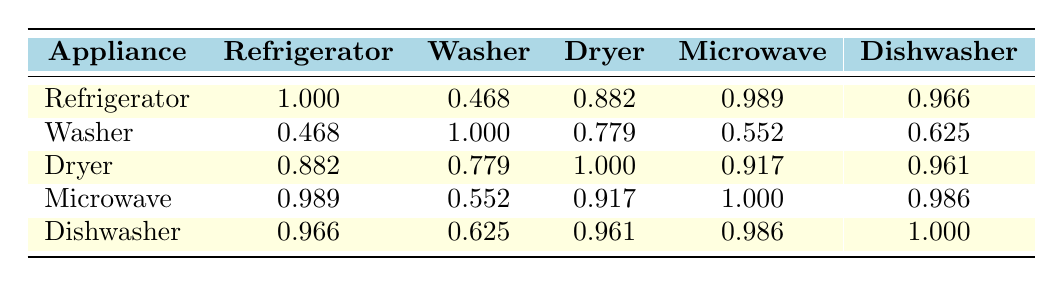What is the correlation coefficient between refrigerator and microwave sales? Looking at the table, the correlation coefficient for refrigerator and microwave sales is 0.989, indicating a very strong positive correlation.
Answer: 0.989 Are refrigerator sales more strongly correlated with dryer sales or washer sales? The correlation coefficient between refrigerator and dryer sales is 0.882, while for refrigerator and washer sales, it is 0.468. Therefore, refrigerator sales are more strongly correlated with dryer sales.
Answer: Dryer sales What is the average correlation of dishwasher sales with all other appliances? To calculate the average correlation for dishwasher sales, add the correlation coefficients with refrigerator (0.966), washer (0.625), dryer (0.961), and microwave (0.986), which gives a total of 3.238. Dividing by 4 (the number of comparisons) results in an average of 3.238 / 4 = 0.8095.
Answer: 0.8095 Is there a stronger correlation between washer sales and dryer sales or between microwave sales and dishwasher sales? The correlation coefficient for washer and dryer sales is 0.779, while for microwave and dishwasher sales, it is 0.986. Since 0.986 is greater than 0.779, the correlation between microwave and dishwasher sales is stronger.
Answer: Yes Which appliance has the highest average correlation with the rest of the appliances? To find this, we calculate the average correlation for each appliance. For refrigerator: (1.000 + 0.468 + 0.882 + 0.989 + 0.966) / 5 = 0.861, for washer: (0.468 + 1.000 + 0.779 + 0.552 + 0.625) / 5 = 0.692, for dryer: (0.882 + 0.779 + 1.000 + 0.917 + 0.961) / 5 = 0.908, for microwave: (0.989 + 0.552 + 0.917 + 1.000 + 0.986) / 5 = 0.888, and for dishwasher: (0.966 + 0.625 + 0.961 + 0.986 + 1.000) / 5 = 0.913. The highest average correlation is for the dryer at 0.908.
Answer: Dryer 